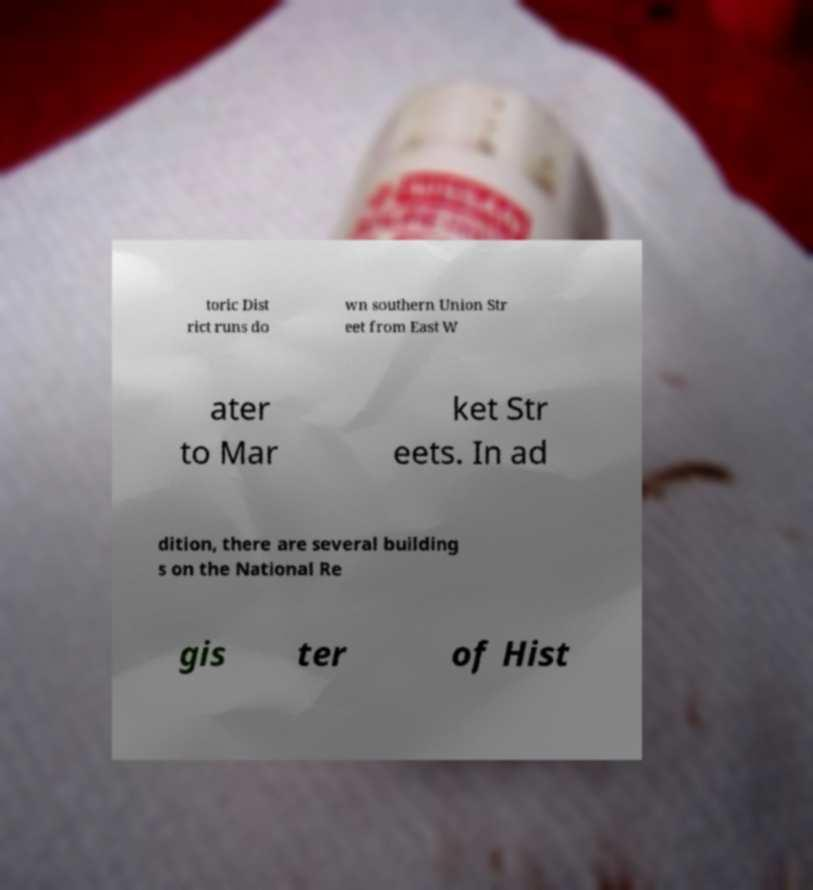There's text embedded in this image that I need extracted. Can you transcribe it verbatim? toric Dist rict runs do wn southern Union Str eet from East W ater to Mar ket Str eets. In ad dition, there are several building s on the National Re gis ter of Hist 